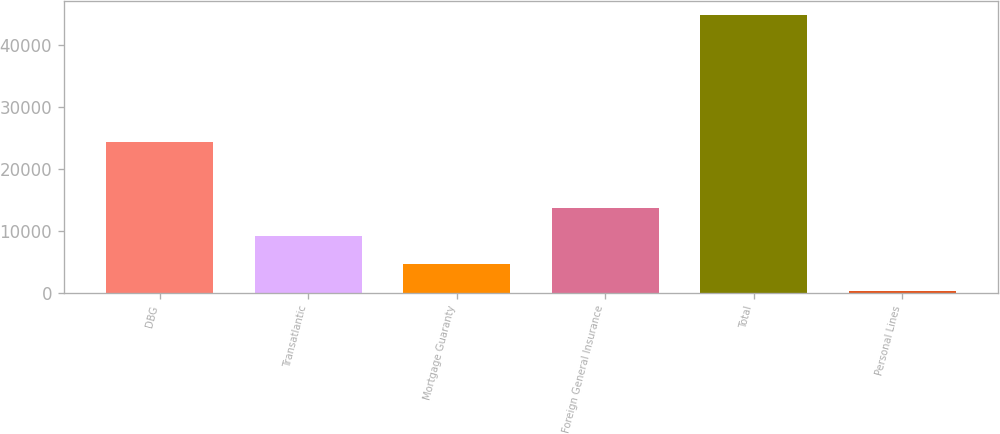Convert chart. <chart><loc_0><loc_0><loc_500><loc_500><bar_chart><fcel>DBG<fcel>Transatlantic<fcel>Mortgage Guaranty<fcel>Foreign General Insurance<fcel>Total<fcel>Personal Lines<nl><fcel>24312<fcel>9153.2<fcel>4689.1<fcel>13617.3<fcel>44866<fcel>225<nl></chart> 